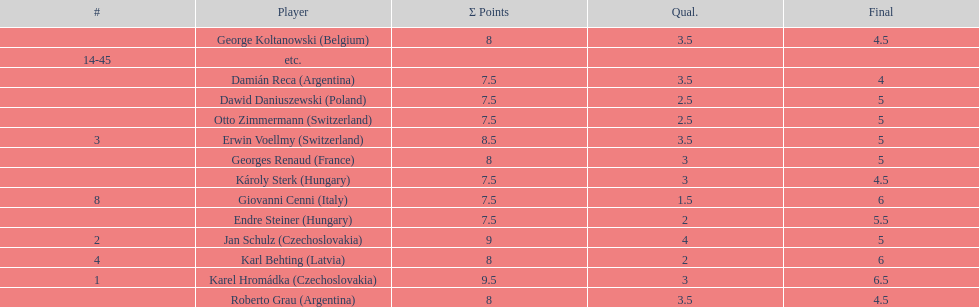From switzerland, who scored the most points? Erwin Voellmy. 